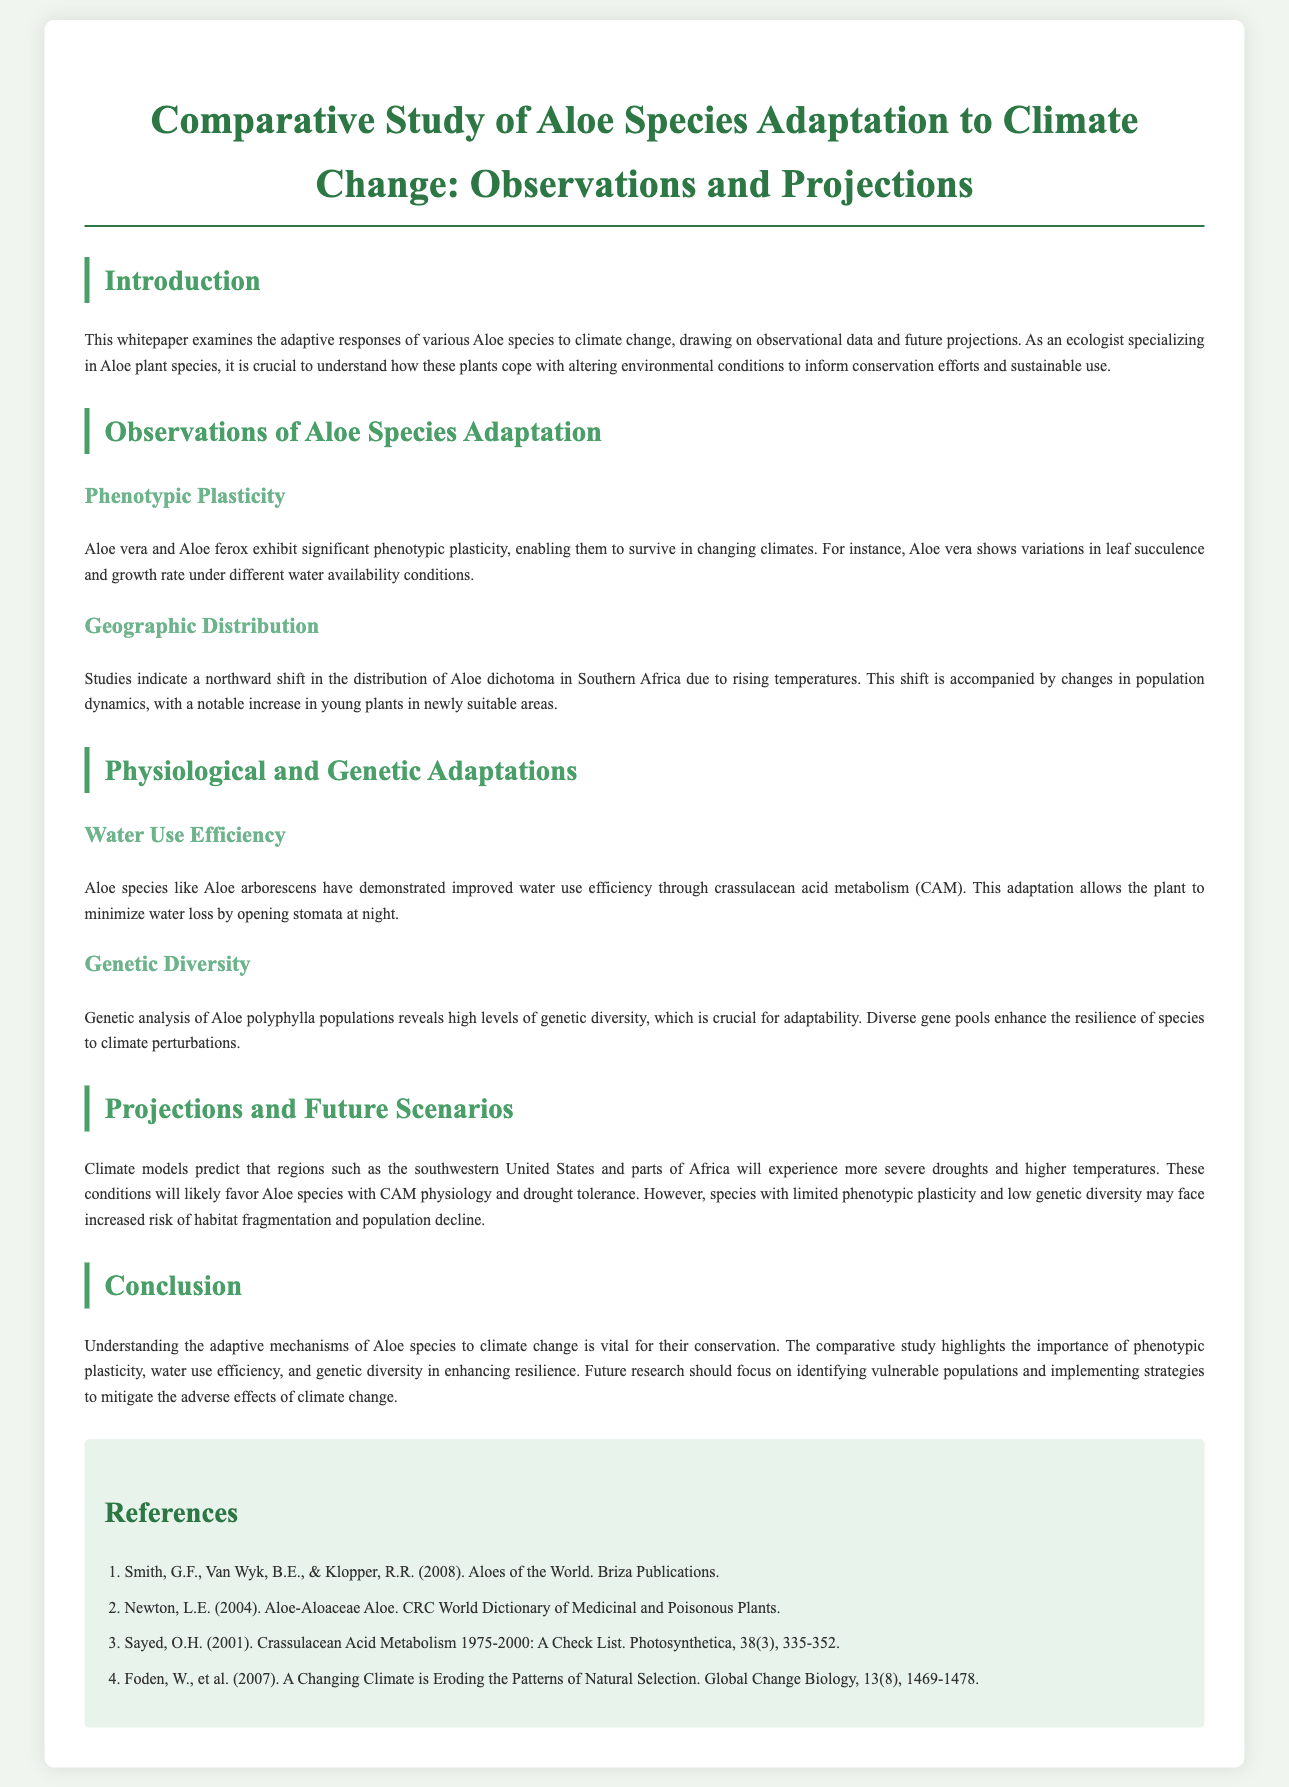What is the main focus of the whitepaper? The document examines the adaptive responses of various Aloe species to climate change, drawing on observational data and future projections.
Answer: Adaptation of Aloe species to climate change Which Aloe species exhibits significant phenotypic plasticity? The text mentions Aloe vera and Aloe ferox as species that have significant phenotypic plasticity, allowing them to survive in changing climates.
Answer: Aloe vera and Aloe ferox What adaptation mechanism does Aloe arborescens use? Aloe arborescens demonstrates improved water use efficiency through crassulacean acid metabolism (CAM), allowing the plant to minimize water loss.
Answer: Crassulacean acid metabolism (CAM) What geographic trend is observed in Aloe dichotoma? The document notes a northward shift in the distribution of Aloe dichotoma in Southern Africa, caused by rising temperatures.
Answer: Northward shift What is noted about the genetic diversity of Aloe polyphylla populations? The genetic analysis reveals high levels of genetic diversity in Aloe polyphylla populations, which is crucial for adaptability to climate perturbations.
Answer: High levels of genetic diversity What future climate condition will likely favor certain Aloe species? The projected future conditions of more severe droughts and higher temperatures are likely to favor Aloe species with CAM physiology and drought tolerance.
Answer: Severe droughts and higher temperatures What should future research focus on according to the document? The conclusion emphasizes that future research should focus on identifying vulnerable populations and implementing strategies to mitigate the adverse effects of climate change.
Answer: Identifying vulnerable populations What is the primary concern of the whitepaper related to conservation? The document highlights understanding the adaptive mechanisms of Aloe species to climate change as vital for their conservation efforts.
Answer: Adaptive mechanisms of Aloe species Which Aloe species is specifically mentioned regarding variations in leaf succulence? Aloe vera is specifically mentioned as showing variations in leaf succulence under different water availability conditions.
Answer: Aloe vera 